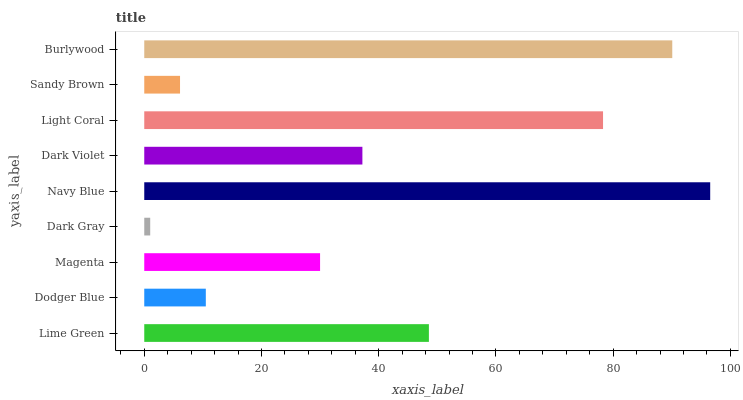Is Dark Gray the minimum?
Answer yes or no. Yes. Is Navy Blue the maximum?
Answer yes or no. Yes. Is Dodger Blue the minimum?
Answer yes or no. No. Is Dodger Blue the maximum?
Answer yes or no. No. Is Lime Green greater than Dodger Blue?
Answer yes or no. Yes. Is Dodger Blue less than Lime Green?
Answer yes or no. Yes. Is Dodger Blue greater than Lime Green?
Answer yes or no. No. Is Lime Green less than Dodger Blue?
Answer yes or no. No. Is Dark Violet the high median?
Answer yes or no. Yes. Is Dark Violet the low median?
Answer yes or no. Yes. Is Sandy Brown the high median?
Answer yes or no. No. Is Dark Gray the low median?
Answer yes or no. No. 